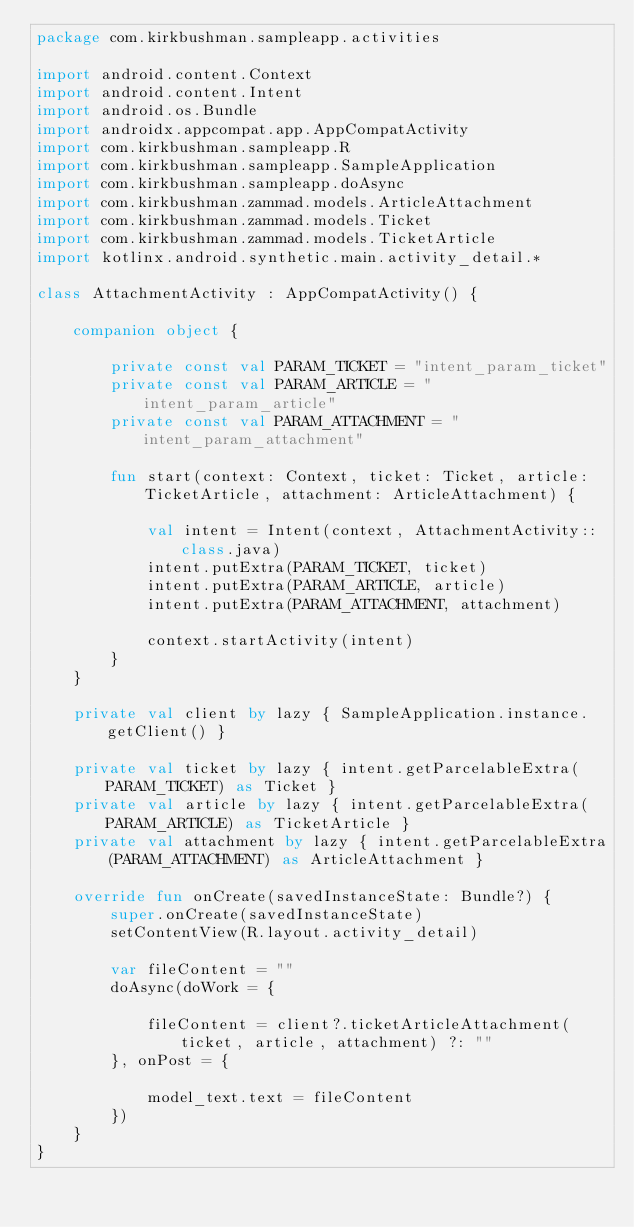<code> <loc_0><loc_0><loc_500><loc_500><_Kotlin_>package com.kirkbushman.sampleapp.activities

import android.content.Context
import android.content.Intent
import android.os.Bundle
import androidx.appcompat.app.AppCompatActivity
import com.kirkbushman.sampleapp.R
import com.kirkbushman.sampleapp.SampleApplication
import com.kirkbushman.sampleapp.doAsync
import com.kirkbushman.zammad.models.ArticleAttachment
import com.kirkbushman.zammad.models.Ticket
import com.kirkbushman.zammad.models.TicketArticle
import kotlinx.android.synthetic.main.activity_detail.*

class AttachmentActivity : AppCompatActivity() {

    companion object {

        private const val PARAM_TICKET = "intent_param_ticket"
        private const val PARAM_ARTICLE = "intent_param_article"
        private const val PARAM_ATTACHMENT = "intent_param_attachment"

        fun start(context: Context, ticket: Ticket, article: TicketArticle, attachment: ArticleAttachment) {

            val intent = Intent(context, AttachmentActivity::class.java)
            intent.putExtra(PARAM_TICKET, ticket)
            intent.putExtra(PARAM_ARTICLE, article)
            intent.putExtra(PARAM_ATTACHMENT, attachment)

            context.startActivity(intent)
        }
    }

    private val client by lazy { SampleApplication.instance.getClient() }

    private val ticket by lazy { intent.getParcelableExtra(PARAM_TICKET) as Ticket }
    private val article by lazy { intent.getParcelableExtra(PARAM_ARTICLE) as TicketArticle }
    private val attachment by lazy { intent.getParcelableExtra(PARAM_ATTACHMENT) as ArticleAttachment }

    override fun onCreate(savedInstanceState: Bundle?) {
        super.onCreate(savedInstanceState)
        setContentView(R.layout.activity_detail)

        var fileContent = ""
        doAsync(doWork = {

            fileContent = client?.ticketArticleAttachment(ticket, article, attachment) ?: ""
        }, onPost = {

            model_text.text = fileContent
        })
    }
}
</code> 